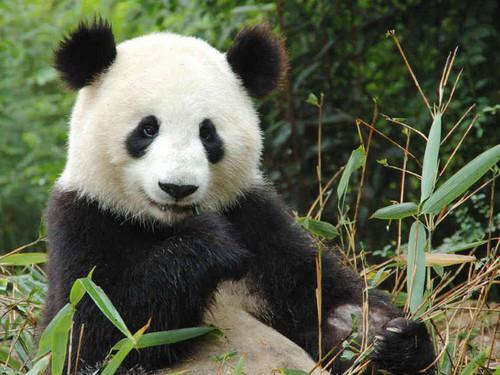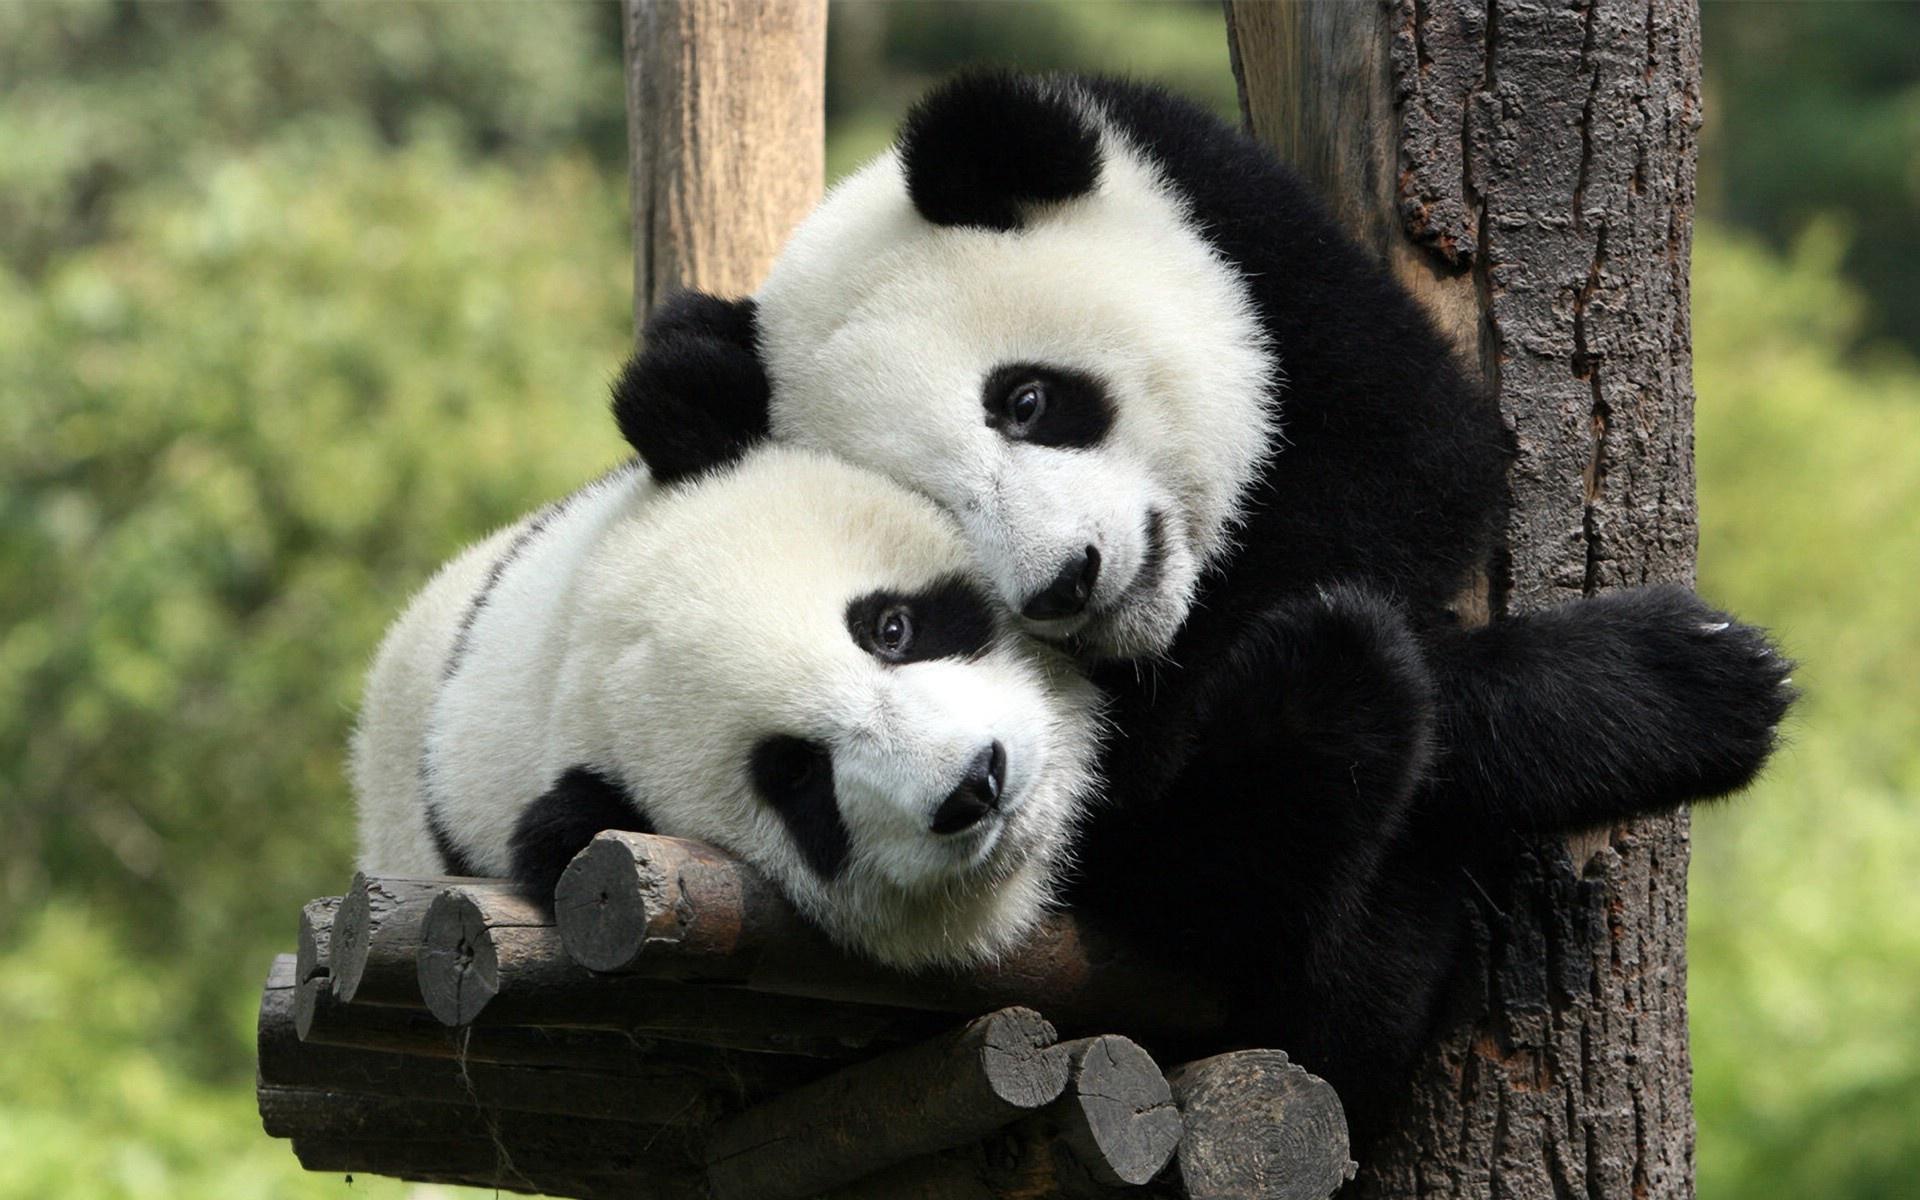The first image is the image on the left, the second image is the image on the right. Assess this claim about the two images: "There are two pandas in the image on the right.". Correct or not? Answer yes or no. Yes. 